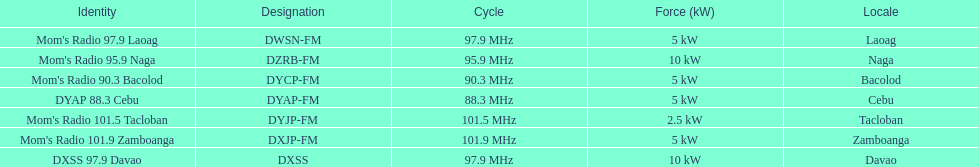What is the last location on this chart? Davao. 